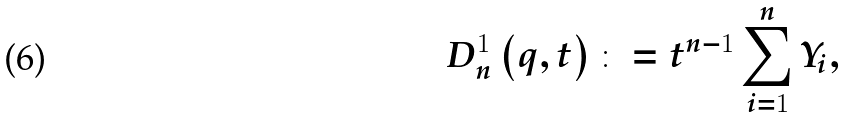<formula> <loc_0><loc_0><loc_500><loc_500>D _ { n } ^ { 1 } \left ( q , t \right ) \colon = t ^ { n - 1 } \sum _ { i = 1 } ^ { n } Y _ { i } ,</formula> 